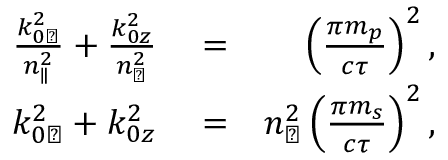Convert formula to latex. <formula><loc_0><loc_0><loc_500><loc_500>\begin{array} { r l r } { \frac { k _ { 0 \perp } ^ { 2 } } { n _ { \| } ^ { 2 } } + \frac { k _ { 0 z } ^ { 2 } } { n _ { \perp } ^ { 2 } } } & = } & { \left ( \frac { \pi m _ { p } } { c \tau } \right ) ^ { 2 } , } \\ { k _ { 0 \perp } ^ { 2 } + k _ { 0 z } ^ { 2 } } & = } & { n _ { \perp } ^ { 2 } \left ( \frac { \pi m _ { s } } { c \tau } \right ) ^ { 2 } , } \end{array}</formula> 